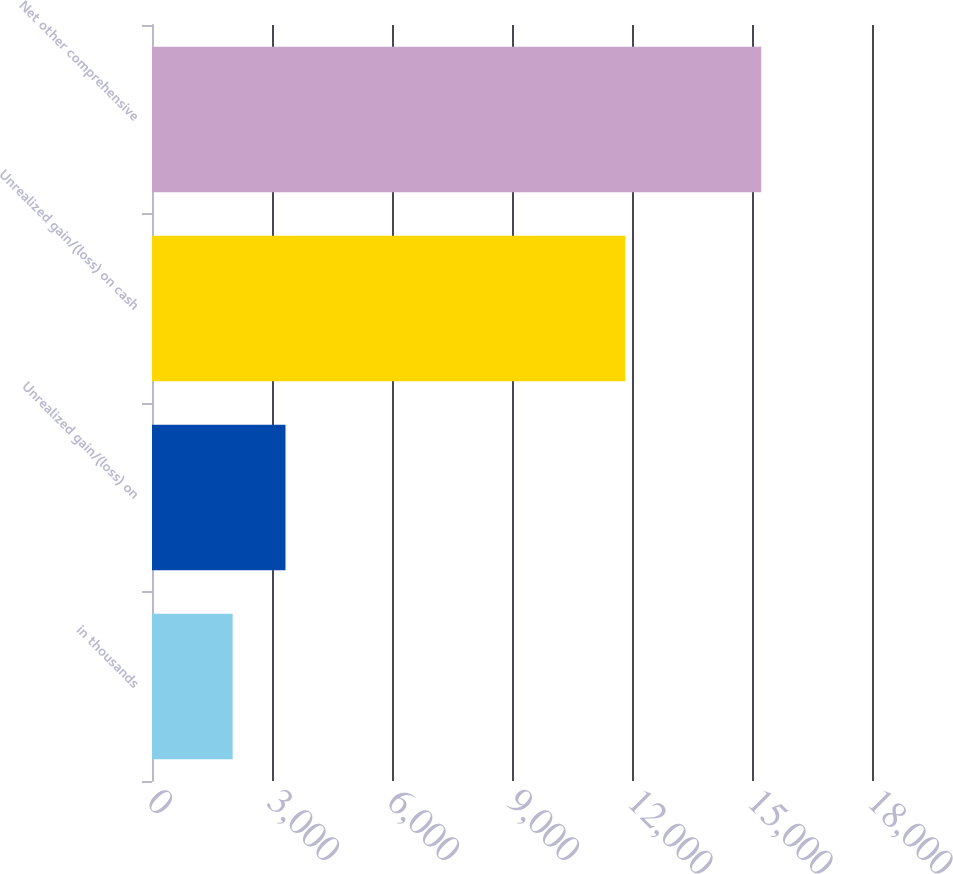Convert chart to OTSL. <chart><loc_0><loc_0><loc_500><loc_500><bar_chart><fcel>in thousands<fcel>Unrealized gain/(loss) on<fcel>Unrealized gain/(loss) on cash<fcel>Net other comprehensive<nl><fcel>2016<fcel>3337.4<fcel>11833<fcel>15230<nl></chart> 